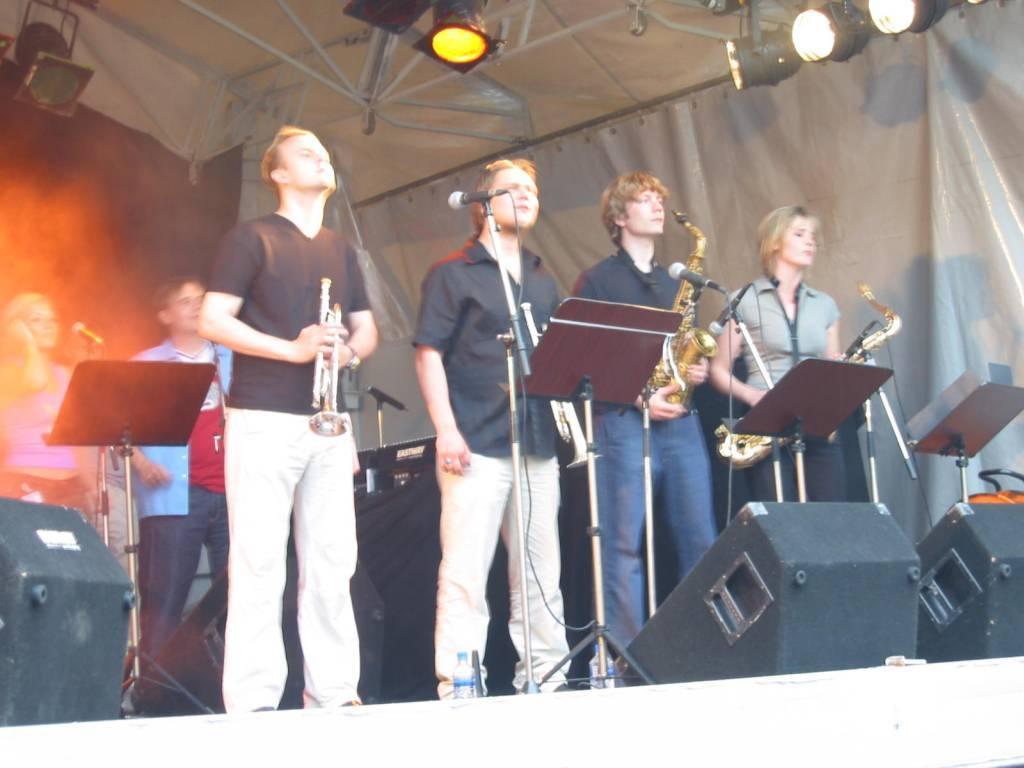Could you give a brief overview of what you see in this image? In the foreground we can see four persons standing on the stage. They are holding saxophones in their hands. Here we can see the microphones with stands on the stage. In the background, we can see two people standing on the stage. Here we can see the lighting arrangement on the top right side. 